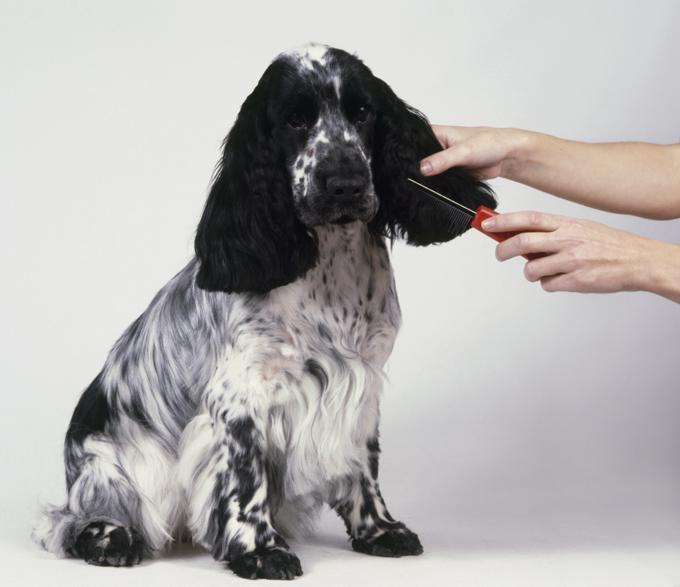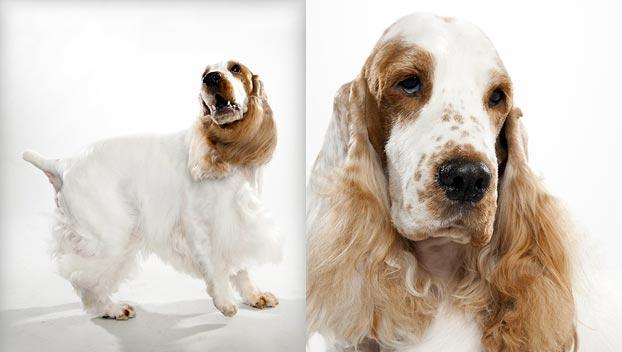The first image is the image on the left, the second image is the image on the right. Given the left and right images, does the statement "Five spaniels are shown, in total." hold true? Answer yes or no. No. The first image is the image on the left, the second image is the image on the right. Assess this claim about the two images: "There are at most two dogs.". Correct or not? Answer yes or no. No. The first image is the image on the left, the second image is the image on the right. Given the left and right images, does the statement "The right image contains exactly three dogs." hold true? Answer yes or no. No. 